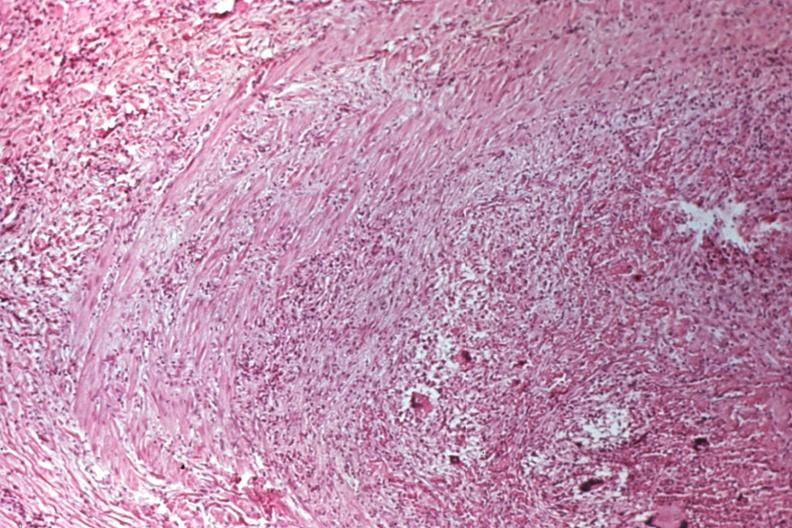what does this image show?
Answer the question using a single word or phrase. Migratory thrombophlebitis 